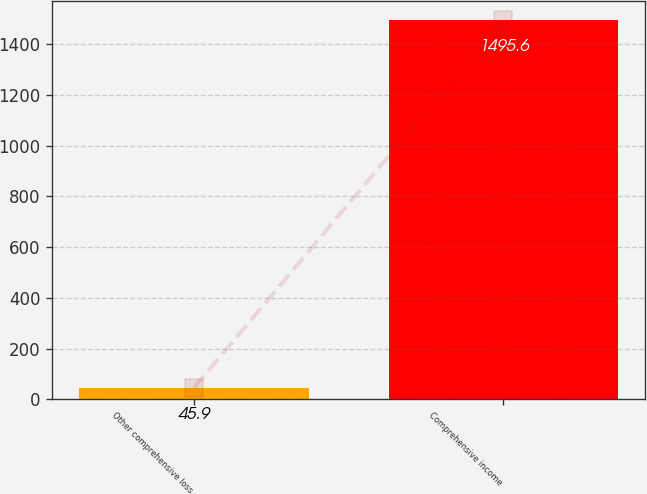Convert chart. <chart><loc_0><loc_0><loc_500><loc_500><bar_chart><fcel>Other comprehensive loss<fcel>Comprehensive income<nl><fcel>45.9<fcel>1495.6<nl></chart> 